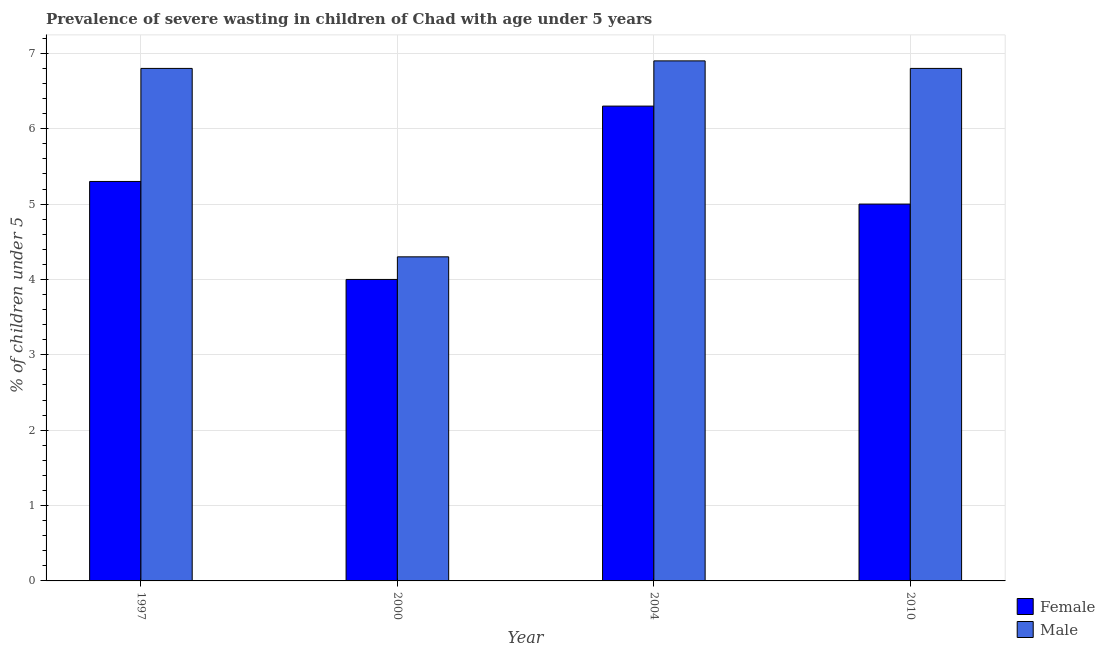How many groups of bars are there?
Your answer should be very brief. 4. Are the number of bars on each tick of the X-axis equal?
Provide a short and direct response. Yes. How many bars are there on the 4th tick from the right?
Offer a terse response. 2. What is the label of the 3rd group of bars from the left?
Give a very brief answer. 2004. What is the percentage of undernourished female children in 2000?
Keep it short and to the point. 4. Across all years, what is the maximum percentage of undernourished female children?
Offer a very short reply. 6.3. Across all years, what is the minimum percentage of undernourished male children?
Your answer should be compact. 4.3. In which year was the percentage of undernourished male children maximum?
Provide a succinct answer. 2004. What is the total percentage of undernourished male children in the graph?
Provide a succinct answer. 24.8. What is the difference between the percentage of undernourished male children in 2000 and that in 2010?
Your answer should be very brief. -2.5. What is the average percentage of undernourished female children per year?
Provide a succinct answer. 5.15. In how many years, is the percentage of undernourished female children greater than 1.8 %?
Make the answer very short. 4. What is the ratio of the percentage of undernourished female children in 1997 to that in 2010?
Your response must be concise. 1.06. What is the difference between the highest and the second highest percentage of undernourished male children?
Your answer should be compact. 0.1. What is the difference between the highest and the lowest percentage of undernourished female children?
Give a very brief answer. 2.3. What does the 2nd bar from the left in 2010 represents?
Ensure brevity in your answer.  Male. What does the 1st bar from the right in 2000 represents?
Your answer should be compact. Male. Are the values on the major ticks of Y-axis written in scientific E-notation?
Give a very brief answer. No. Does the graph contain any zero values?
Provide a succinct answer. No. Does the graph contain grids?
Keep it short and to the point. Yes. Where does the legend appear in the graph?
Your answer should be very brief. Bottom right. How are the legend labels stacked?
Provide a short and direct response. Vertical. What is the title of the graph?
Keep it short and to the point. Prevalence of severe wasting in children of Chad with age under 5 years. Does "Taxes on exports" appear as one of the legend labels in the graph?
Give a very brief answer. No. What is the label or title of the X-axis?
Give a very brief answer. Year. What is the label or title of the Y-axis?
Your answer should be compact.  % of children under 5. What is the  % of children under 5 in Female in 1997?
Provide a short and direct response. 5.3. What is the  % of children under 5 of Male in 1997?
Give a very brief answer. 6.8. What is the  % of children under 5 of Male in 2000?
Offer a very short reply. 4.3. What is the  % of children under 5 of Female in 2004?
Your response must be concise. 6.3. What is the  % of children under 5 in Male in 2004?
Offer a terse response. 6.9. What is the  % of children under 5 of Male in 2010?
Provide a short and direct response. 6.8. Across all years, what is the maximum  % of children under 5 in Female?
Provide a succinct answer. 6.3. Across all years, what is the maximum  % of children under 5 in Male?
Offer a very short reply. 6.9. Across all years, what is the minimum  % of children under 5 of Male?
Ensure brevity in your answer.  4.3. What is the total  % of children under 5 in Female in the graph?
Offer a terse response. 20.6. What is the total  % of children under 5 in Male in the graph?
Offer a terse response. 24.8. What is the difference between the  % of children under 5 of Female in 1997 and that in 2004?
Your answer should be compact. -1. What is the difference between the  % of children under 5 in Female in 1997 and that in 2010?
Keep it short and to the point. 0.3. What is the difference between the  % of children under 5 of Male in 1997 and that in 2010?
Provide a succinct answer. 0. What is the difference between the  % of children under 5 of Male in 2000 and that in 2004?
Make the answer very short. -2.6. What is the difference between the  % of children under 5 of Female in 2000 and that in 2010?
Make the answer very short. -1. What is the difference between the  % of children under 5 of Male in 2004 and that in 2010?
Your response must be concise. 0.1. What is the difference between the  % of children under 5 of Female in 1997 and the  % of children under 5 of Male in 2000?
Provide a succinct answer. 1. What is the difference between the  % of children under 5 in Female in 1997 and the  % of children under 5 in Male in 2004?
Your response must be concise. -1.6. What is the difference between the  % of children under 5 of Female in 2004 and the  % of children under 5 of Male in 2010?
Give a very brief answer. -0.5. What is the average  % of children under 5 of Female per year?
Your answer should be very brief. 5.15. In the year 2004, what is the difference between the  % of children under 5 in Female and  % of children under 5 in Male?
Offer a very short reply. -0.6. In the year 2010, what is the difference between the  % of children under 5 in Female and  % of children under 5 in Male?
Your answer should be compact. -1.8. What is the ratio of the  % of children under 5 of Female in 1997 to that in 2000?
Offer a terse response. 1.32. What is the ratio of the  % of children under 5 of Male in 1997 to that in 2000?
Keep it short and to the point. 1.58. What is the ratio of the  % of children under 5 of Female in 1997 to that in 2004?
Your answer should be very brief. 0.84. What is the ratio of the  % of children under 5 in Male in 1997 to that in 2004?
Provide a succinct answer. 0.99. What is the ratio of the  % of children under 5 of Female in 1997 to that in 2010?
Keep it short and to the point. 1.06. What is the ratio of the  % of children under 5 of Female in 2000 to that in 2004?
Offer a terse response. 0.63. What is the ratio of the  % of children under 5 of Male in 2000 to that in 2004?
Make the answer very short. 0.62. What is the ratio of the  % of children under 5 in Male in 2000 to that in 2010?
Offer a terse response. 0.63. What is the ratio of the  % of children under 5 in Female in 2004 to that in 2010?
Your answer should be very brief. 1.26. What is the ratio of the  % of children under 5 in Male in 2004 to that in 2010?
Offer a terse response. 1.01. 